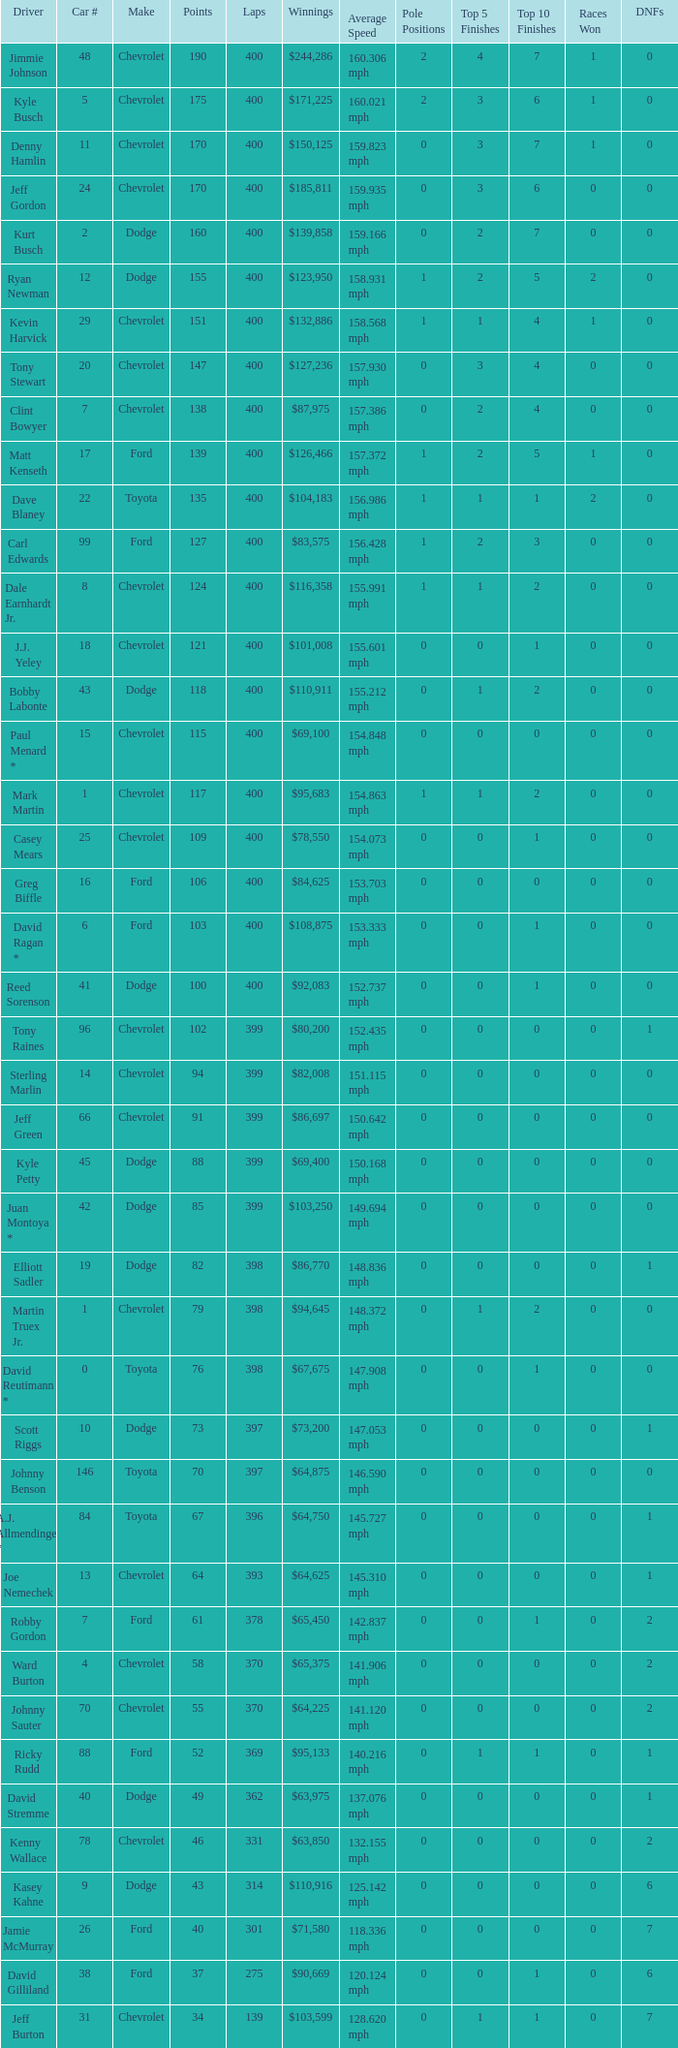Would you be able to parse every entry in this table? {'header': ['Driver', 'Car #', 'Make', 'Points', 'Laps', 'Winnings', 'Average Speed', 'Pole Positions', 'Top 5 Finishes', 'Top 10 Finishes', 'Races Won', 'DNFs'], 'rows': [['Jimmie Johnson', '48', 'Chevrolet', '190', '400', '$244,286', '160.306 mph', '2', '4', '7', '1', '0'], ['Kyle Busch', '5', 'Chevrolet', '175', '400', '$171,225', '160.021 mph', '2', '3', '6', '1', '0'], ['Denny Hamlin', '11', 'Chevrolet', '170', '400', '$150,125', '159.823 mph', '0', '3', '7', '1', '0'], ['Jeff Gordon', '24', 'Chevrolet', '170', '400', '$185,811', '159.935 mph', '0', '3', '6', '0', '0'], ['Kurt Busch', '2', 'Dodge', '160', '400', '$139,858', '159.166 mph', '0', '2', '7', '0', '0'], ['Ryan Newman', '12', 'Dodge', '155', '400', '$123,950', '158.931 mph', '1', '2', '5', '2', '0'], ['Kevin Harvick', '29', 'Chevrolet', '151', '400', '$132,886', '158.568 mph', '1', '1', '4', '1', '0'], ['Tony Stewart', '20', 'Chevrolet', '147', '400', '$127,236', '157.930 mph', '0', '3', '4', '0', '0'], ['Clint Bowyer', '7', 'Chevrolet', '138', '400', '$87,975', '157.386 mph', '0', '2', '4', '0', '0'], ['Matt Kenseth', '17', 'Ford', '139', '400', '$126,466', '157.372 mph', '1', '2', '5', '1', '0'], ['Dave Blaney', '22', 'Toyota', '135', '400', '$104,183', '156.986 mph', '1', '1', '1', '2', '0'], ['Carl Edwards', '99', 'Ford', '127', '400', '$83,575', '156.428 mph', '1', '2', '3', '0', '0'], ['Dale Earnhardt Jr.', '8', 'Chevrolet', '124', '400', '$116,358', '155.991 mph', '1', '1', '2', '0', '0'], ['J.J. Yeley', '18', 'Chevrolet', '121', '400', '$101,008', '155.601 mph', '0', '0', '1', '0', '0'], ['Bobby Labonte', '43', 'Dodge', '118', '400', '$110,911', '155.212 mph', '0', '1', '2', '0', '0'], ['Paul Menard *', '15', 'Chevrolet', '115', '400', '$69,100', '154.848 mph', '0', '0', '0', '0', '0'], ['Mark Martin', '1', 'Chevrolet', '117', '400', '$95,683', '154.863 mph', '1', '1', '2', '0', '0'], ['Casey Mears', '25', 'Chevrolet', '109', '400', '$78,550', '154.073 mph', '0', '0', '1', '0', '0'], ['Greg Biffle', '16', 'Ford', '106', '400', '$84,625', '153.703 mph', '0', '0', '0', '0', '0'], ['David Ragan *', '6', 'Ford', '103', '400', '$108,875', '153.333 mph', '0', '0', '1', '0', '0'], ['Reed Sorenson', '41', 'Dodge', '100', '400', '$92,083', '152.737 mph', '0', '0', '1', '0', '0'], ['Tony Raines', '96', 'Chevrolet', '102', '399', '$80,200', '152.435 mph', '0', '0', '0', '0', '1'], ['Sterling Marlin', '14', 'Chevrolet', '94', '399', '$82,008', '151.115 mph', '0', '0', '0', '0', '0'], ['Jeff Green', '66', 'Chevrolet', '91', '399', '$86,697', '150.642 mph', '0', '0', '0', '0', '0'], ['Kyle Petty', '45', 'Dodge', '88', '399', '$69,400', '150.168 mph', '0', '0', '0', '0', '0'], ['Juan Montoya *', '42', 'Dodge', '85', '399', '$103,250', '149.694 mph', '0', '0', '0', '0', '0'], ['Elliott Sadler', '19', 'Dodge', '82', '398', '$86,770', '148.836 mph', '0', '0', '0', '0', '1'], ['Martin Truex Jr.', '1', 'Chevrolet', '79', '398', '$94,645', '148.372 mph', '0', '1', '2', '0', '0'], ['David Reutimann *', '0', 'Toyota', '76', '398', '$67,675', '147.908 mph', '0', '0', '1', '0', '0'], ['Scott Riggs', '10', 'Dodge', '73', '397', '$73,200', '147.053 mph', '0', '0', '0', '0', '1'], ['Johnny Benson', '146', 'Toyota', '70', '397', '$64,875', '146.590 mph', '0', '0', '0', '0', '0'], ['A.J. Allmendinger *', '84', 'Toyota', '67', '396', '$64,750', '145.727 mph', '0', '0', '0', '0', '1'], ['Joe Nemechek', '13', 'Chevrolet', '64', '393', '$64,625', '145.310 mph', '0', '0', '0', '0', '1'], ['Robby Gordon', '7', 'Ford', '61', '378', '$65,450', '142.837 mph', '0', '0', '1', '0', '2'], ['Ward Burton', '4', 'Chevrolet', '58', '370', '$65,375', '141.906 mph', '0', '0', '0', '0', '2'], ['Johnny Sauter', '70', 'Chevrolet', '55', '370', '$64,225', '141.120 mph', '0', '0', '0', '0', '2'], ['Ricky Rudd', '88', 'Ford', '52', '369', '$95,133', '140.216 mph', '0', '1', '1', '0', '1'], ['David Stremme', '40', 'Dodge', '49', '362', '$63,975', '137.076 mph', '0', '0', '0', '0', '1'], ['Kenny Wallace', '78', 'Chevrolet', '46', '331', '$63,850', '132.155 mph', '0', '0', '0', '0', '2'], ['Kasey Kahne', '9', 'Dodge', '43', '314', '$110,916', '125.142 mph', '0', '0', '0', '0', '6'], ['Jamie McMurray', '26', 'Ford', '40', '301', '$71,580', '118.336 mph', '0', '0', '0', '0', '7'], ['David Gilliland', '38', 'Ford', '37', '275', '$90,669', '120.124 mph', '0', '0', '1', '0', '6'], ['Jeff Burton', '31', 'Chevrolet', '34', '139', '$103,599', '128.620 mph', '0', '1', '1', '0', '7']]} What is the make of car 31? Chevrolet. 